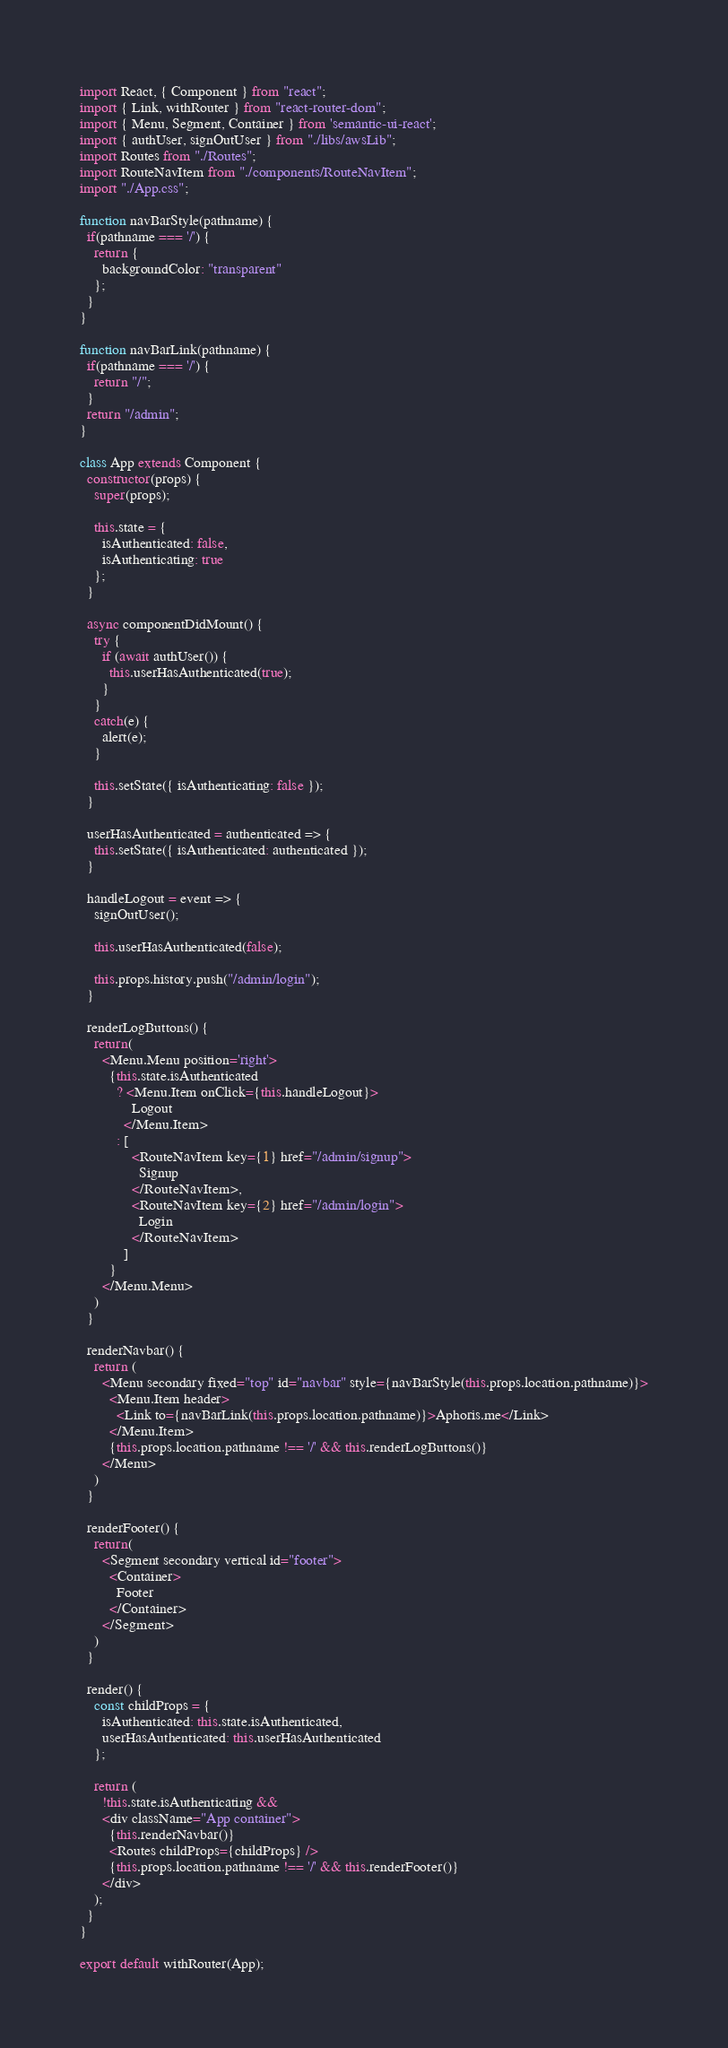<code> <loc_0><loc_0><loc_500><loc_500><_JavaScript_>import React, { Component } from "react";
import { Link, withRouter } from "react-router-dom";
import { Menu, Segment, Container } from 'semantic-ui-react';
import { authUser, signOutUser } from "./libs/awsLib";
import Routes from "./Routes";
import RouteNavItem from "./components/RouteNavItem";
import "./App.css";

function navBarStyle(pathname) {
  if(pathname === '/') {
    return {
      backgroundColor: "transparent"
    };
  }
}

function navBarLink(pathname) {
  if(pathname === '/') {
    return "/";
  }
  return "/admin";
}

class App extends Component {
  constructor(props) {
    super(props);

    this.state = {
      isAuthenticated: false,
      isAuthenticating: true
    };
  }

  async componentDidMount() {
    try {
      if (await authUser()) {
        this.userHasAuthenticated(true);
      }
    }
    catch(e) {
      alert(e);
    }

    this.setState({ isAuthenticating: false });
  }

  userHasAuthenticated = authenticated => {
    this.setState({ isAuthenticated: authenticated });
  }

  handleLogout = event => {
    signOutUser();

    this.userHasAuthenticated(false);

    this.props.history.push("/admin/login");
  }

  renderLogButtons() {
    return(
      <Menu.Menu position='right'>
        {this.state.isAuthenticated
          ? <Menu.Item onClick={this.handleLogout}>
              Logout
            </Menu.Item>
          : [
              <RouteNavItem key={1} href="/admin/signup">
                Signup
              </RouteNavItem>,
              <RouteNavItem key={2} href="/admin/login">
                Login
              </RouteNavItem>
            ]
        }
      </Menu.Menu>
    )
  }

  renderNavbar() {
    return (
      <Menu secondary fixed="top" id="navbar" style={navBarStyle(this.props.location.pathname)}>
        <Menu.Item header>
          <Link to={navBarLink(this.props.location.pathname)}>Aphoris.me</Link>
        </Menu.Item>
        {this.props.location.pathname !== '/' && this.renderLogButtons()}
      </Menu>
    )
  }

  renderFooter() {
    return(
      <Segment secondary vertical id="footer">
        <Container>
          Footer
        </Container>
      </Segment>
    )
  }

  render() {
    const childProps = {
      isAuthenticated: this.state.isAuthenticated,
      userHasAuthenticated: this.userHasAuthenticated
    };

    return (
      !this.state.isAuthenticating &&
      <div className="App container">
        {this.renderNavbar()}
        <Routes childProps={childProps} />
        {this.props.location.pathname !== '/' && this.renderFooter()}
      </div>
    );
  }
}

export default withRouter(App);
</code> 